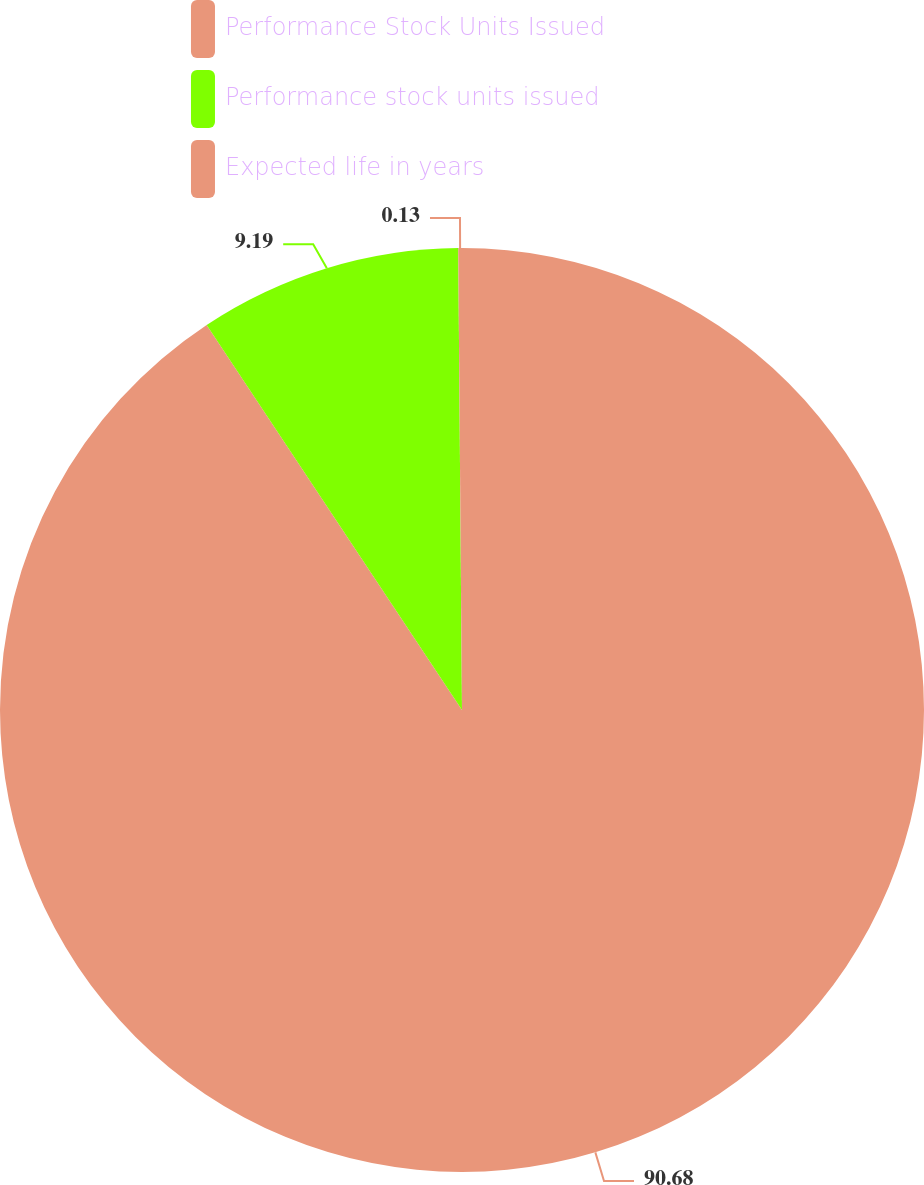Convert chart to OTSL. <chart><loc_0><loc_0><loc_500><loc_500><pie_chart><fcel>Performance Stock Units Issued<fcel>Performance stock units issued<fcel>Expected life in years<nl><fcel>90.68%<fcel>9.19%<fcel>0.13%<nl></chart> 